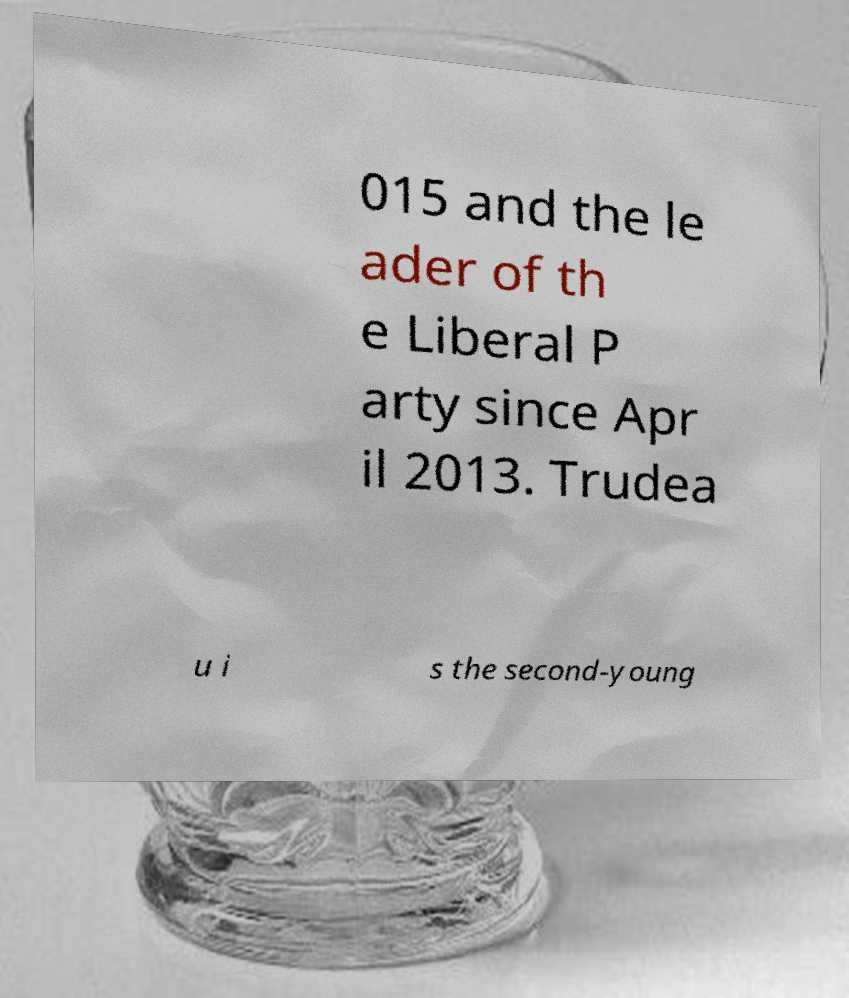For documentation purposes, I need the text within this image transcribed. Could you provide that? 015 and the le ader of th e Liberal P arty since Apr il 2013. Trudea u i s the second-young 